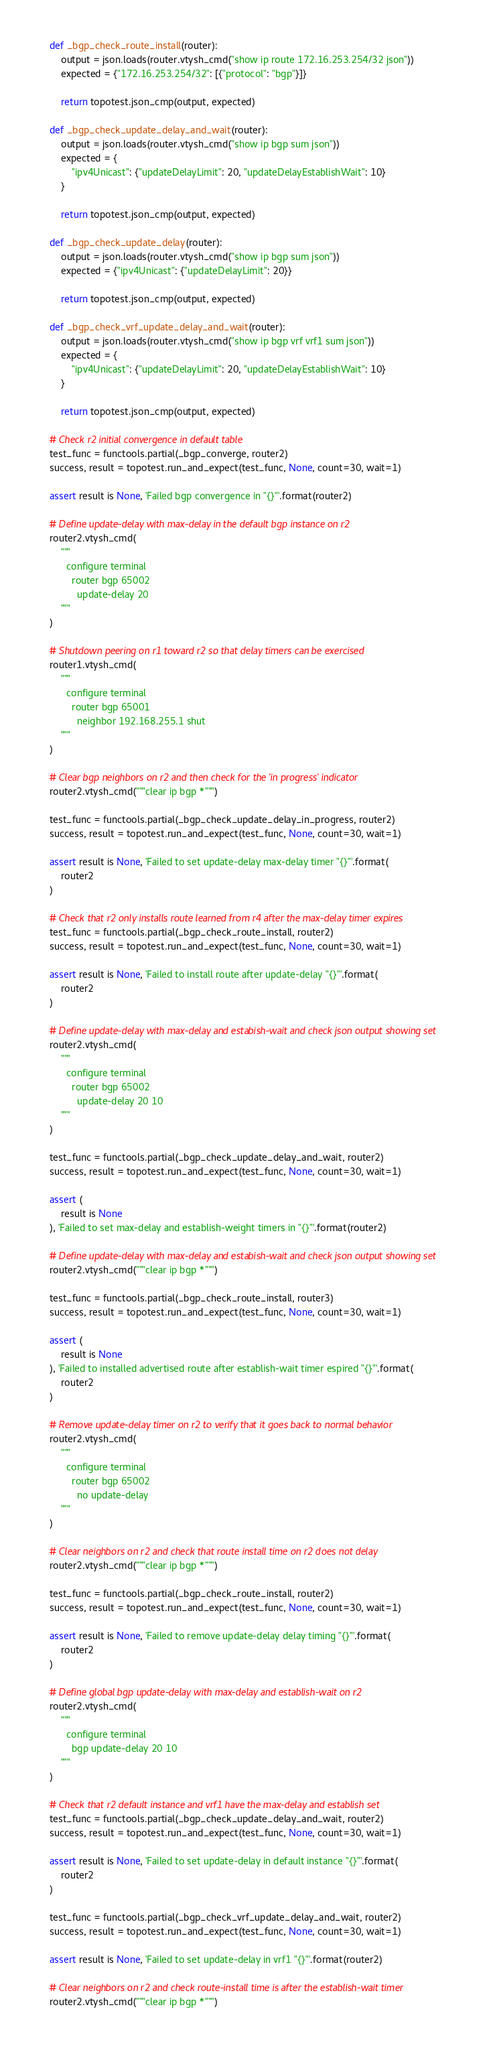<code> <loc_0><loc_0><loc_500><loc_500><_Python_>    def _bgp_check_route_install(router):
        output = json.loads(router.vtysh_cmd("show ip route 172.16.253.254/32 json"))
        expected = {"172.16.253.254/32": [{"protocol": "bgp"}]}

        return topotest.json_cmp(output, expected)

    def _bgp_check_update_delay_and_wait(router):
        output = json.loads(router.vtysh_cmd("show ip bgp sum json"))
        expected = {
            "ipv4Unicast": {"updateDelayLimit": 20, "updateDelayEstablishWait": 10}
        }

        return topotest.json_cmp(output, expected)

    def _bgp_check_update_delay(router):
        output = json.loads(router.vtysh_cmd("show ip bgp sum json"))
        expected = {"ipv4Unicast": {"updateDelayLimit": 20}}

        return topotest.json_cmp(output, expected)

    def _bgp_check_vrf_update_delay_and_wait(router):
        output = json.loads(router.vtysh_cmd("show ip bgp vrf vrf1 sum json"))
        expected = {
            "ipv4Unicast": {"updateDelayLimit": 20, "updateDelayEstablishWait": 10}
        }

        return topotest.json_cmp(output, expected)

    # Check r2 initial convergence in default table
    test_func = functools.partial(_bgp_converge, router2)
    success, result = topotest.run_and_expect(test_func, None, count=30, wait=1)

    assert result is None, 'Failed bgp convergence in "{}"'.format(router2)

    # Define update-delay with max-delay in the default bgp instance on r2
    router2.vtysh_cmd(
        """
          configure terminal
            router bgp 65002
              update-delay 20
        """
    )

    # Shutdown peering on r1 toward r2 so that delay timers can be exercised
    router1.vtysh_cmd(
        """
          configure terminal
            router bgp 65001
              neighbor 192.168.255.1 shut
        """
    )

    # Clear bgp neighbors on r2 and then check for the 'in progress' indicator
    router2.vtysh_cmd("""clear ip bgp *""")

    test_func = functools.partial(_bgp_check_update_delay_in_progress, router2)
    success, result = topotest.run_and_expect(test_func, None, count=30, wait=1)

    assert result is None, 'Failed to set update-delay max-delay timer "{}"'.format(
        router2
    )

    # Check that r2 only installs route learned from r4 after the max-delay timer expires
    test_func = functools.partial(_bgp_check_route_install, router2)
    success, result = topotest.run_and_expect(test_func, None, count=30, wait=1)

    assert result is None, 'Failed to install route after update-delay "{}"'.format(
        router2
    )

    # Define update-delay with max-delay and estabish-wait and check json output showing set
    router2.vtysh_cmd(
        """
          configure terminal
            router bgp 65002
              update-delay 20 10
        """
    )

    test_func = functools.partial(_bgp_check_update_delay_and_wait, router2)
    success, result = topotest.run_and_expect(test_func, None, count=30, wait=1)

    assert (
        result is None
    ), 'Failed to set max-delay and establish-weight timers in "{}"'.format(router2)

    # Define update-delay with max-delay and estabish-wait and check json output showing set
    router2.vtysh_cmd("""clear ip bgp *""")

    test_func = functools.partial(_bgp_check_route_install, router3)
    success, result = topotest.run_and_expect(test_func, None, count=30, wait=1)

    assert (
        result is None
    ), 'Failed to installed advertised route after establish-wait timer espired "{}"'.format(
        router2
    )

    # Remove update-delay timer on r2 to verify that it goes back to normal behavior
    router2.vtysh_cmd(
        """
          configure terminal
            router bgp 65002
              no update-delay
        """
    )

    # Clear neighbors on r2 and check that route install time on r2 does not delay
    router2.vtysh_cmd("""clear ip bgp *""")

    test_func = functools.partial(_bgp_check_route_install, router2)
    success, result = topotest.run_and_expect(test_func, None, count=30, wait=1)

    assert result is None, 'Failed to remove update-delay delay timing "{}"'.format(
        router2
    )

    # Define global bgp update-delay with max-delay and establish-wait on r2
    router2.vtysh_cmd(
        """
          configure terminal
            bgp update-delay 20 10
        """
    )

    # Check that r2 default instance and vrf1 have the max-delay and establish set
    test_func = functools.partial(_bgp_check_update_delay_and_wait, router2)
    success, result = topotest.run_and_expect(test_func, None, count=30, wait=1)

    assert result is None, 'Failed to set update-delay in default instance "{}"'.format(
        router2
    )

    test_func = functools.partial(_bgp_check_vrf_update_delay_and_wait, router2)
    success, result = topotest.run_and_expect(test_func, None, count=30, wait=1)

    assert result is None, 'Failed to set update-delay in vrf1 "{}"'.format(router2)

    # Clear neighbors on r2 and check route-install time is after the establish-wait timer
    router2.vtysh_cmd("""clear ip bgp *""")
</code> 